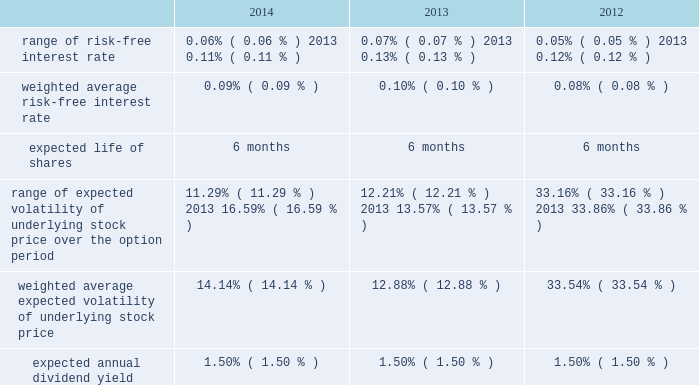American tower corporation and subsidiaries notes to consolidated financial statements six-month offering period .
The weighted average fair value per share of espp share purchase options during the year ended december 31 , 2014 , 2013 and 2012 was $ 14.83 , $ 13.42 and $ 13.64 , respectively .
At december 31 , 2014 , 3.4 million shares remain reserved for future issuance under the plan .
Key assumptions used to apply the black-scholes pricing model for shares purchased through the espp for the years ended december 31 , are as follows: .
16 .
Equity mandatory convertible preferred stock offering 2014on may 12 , 2014 , the company completed a registered public offering of 6000000 shares of its 5.25% ( 5.25 % ) mandatory convertible preferred stock , series a , par value $ 0.01 per share ( the 201cmandatory convertible preferred stock 201d ) .
The net proceeds of the offering were $ 582.9 million after deducting commissions and estimated expenses .
The company used the net proceeds from this offering to fund acquisitions , including the acquisition from richland , initially funded by indebtedness incurred under the 2013 credit facility .
Unless converted earlier , each share of the mandatory convertible preferred stock will automatically convert on may 15 , 2017 , into between 0.9174 and 1.1468 shares of common stock , depending on the applicable market value of the common stock and subject to anti-dilution adjustments .
Subject to certain restrictions , at any time prior to may 15 , 2017 , holders of the mandatory convertible preferred stock may elect to convert all or a portion of their shares into common stock at the minimum conversion rate then in effect .
Dividends on shares of mandatory convertible preferred stock are payable on a cumulative basis when , as and if declared by the company 2019s board of directors ( or an authorized committee thereof ) at an annual rate of 5.25% ( 5.25 % ) on the liquidation preference of $ 100.00 per share , on february 15 , may 15 , august 15 and november 15 of each year , commencing on august 15 , 2014 to , and including , may 15 , 2017 .
The company may pay dividends in cash or , subject to certain limitations , in shares of common stock or any combination of cash and shares of common stock .
The terms of the mandatory convertible preferred stock provide that , unless full cumulative dividends have been paid or set aside for payment on all outstanding mandatory convertible preferred stock for all prior dividend periods , no dividends may be declared or paid on common stock .
Stock repurchase program 2014in march 2011 , the board of directors approved a stock repurchase program , pursuant to which the company is authorized to purchase up to $ 1.5 billion of common stock ( 201c2011 buyback 201d ) .
In september 2013 , the company temporarily suspended repurchases in connection with its acquisition of mipt .
Under the 2011 buyback , the company is authorized to purchase shares from time to time through open market purchases or privately negotiated transactions at prevailing prices in accordance with securities laws and other legal requirements , and subject to market conditions and other factors .
To facilitate repurchases , the company .
What is the growth rate in the weighted average fair value per share of espp share purchase options from 2012 to 2013? 
Computations: ((13.42 - 13.64) / 13.64)
Answer: -0.01613. 